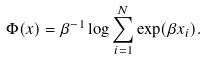<formula> <loc_0><loc_0><loc_500><loc_500>\Phi ( x ) = \beta ^ { - 1 } \log \sum _ { i = 1 } ^ { N } \exp ( \beta x _ { i } ) .</formula> 